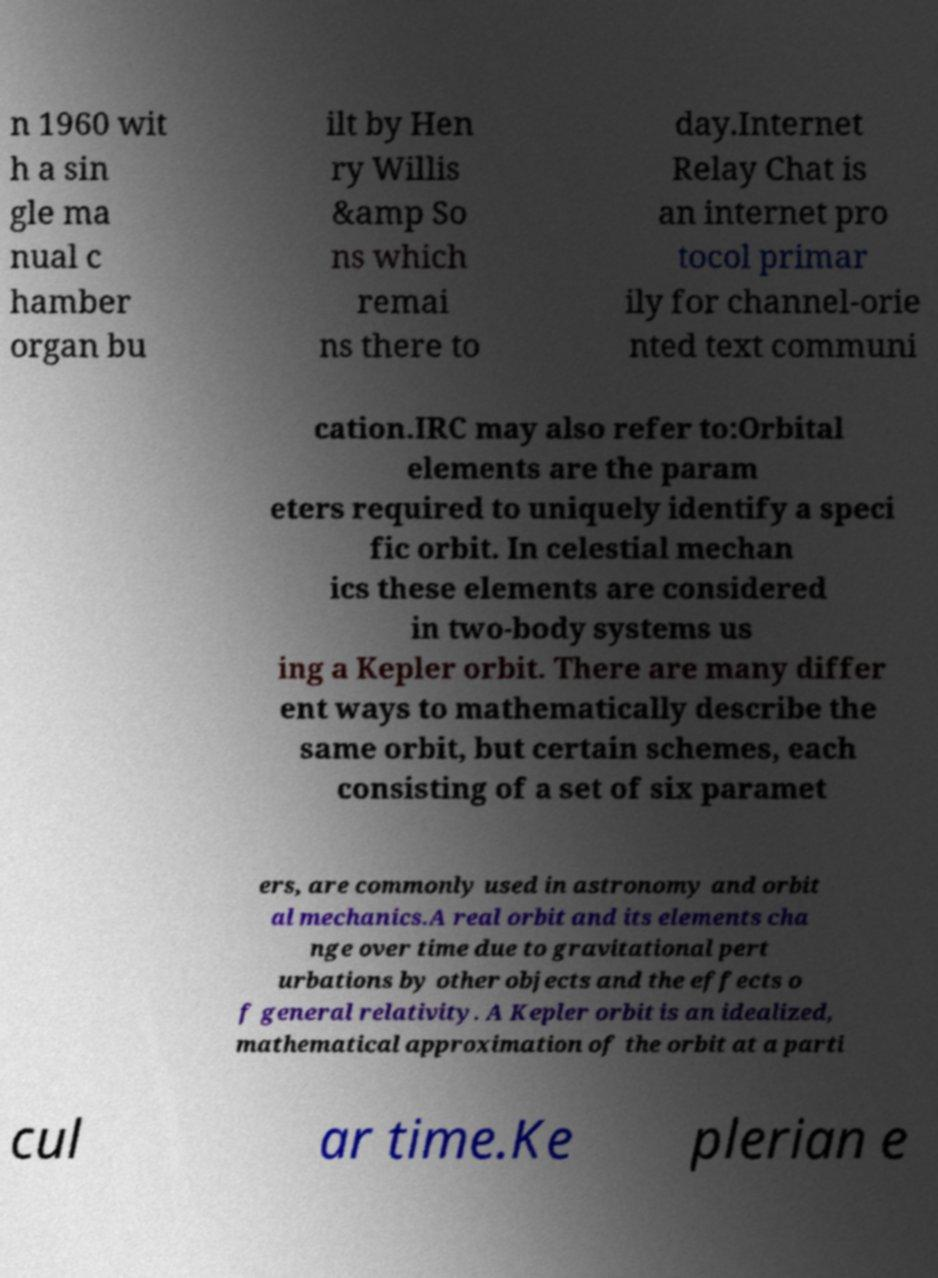Can you read and provide the text displayed in the image?This photo seems to have some interesting text. Can you extract and type it out for me? n 1960 wit h a sin gle ma nual c hamber organ bu ilt by Hen ry Willis &amp So ns which remai ns there to day.Internet Relay Chat is an internet pro tocol primar ily for channel-orie nted text communi cation.IRC may also refer to:Orbital elements are the param eters required to uniquely identify a speci fic orbit. In celestial mechan ics these elements are considered in two-body systems us ing a Kepler orbit. There are many differ ent ways to mathematically describe the same orbit, but certain schemes, each consisting of a set of six paramet ers, are commonly used in astronomy and orbit al mechanics.A real orbit and its elements cha nge over time due to gravitational pert urbations by other objects and the effects o f general relativity. A Kepler orbit is an idealized, mathematical approximation of the orbit at a parti cul ar time.Ke plerian e 